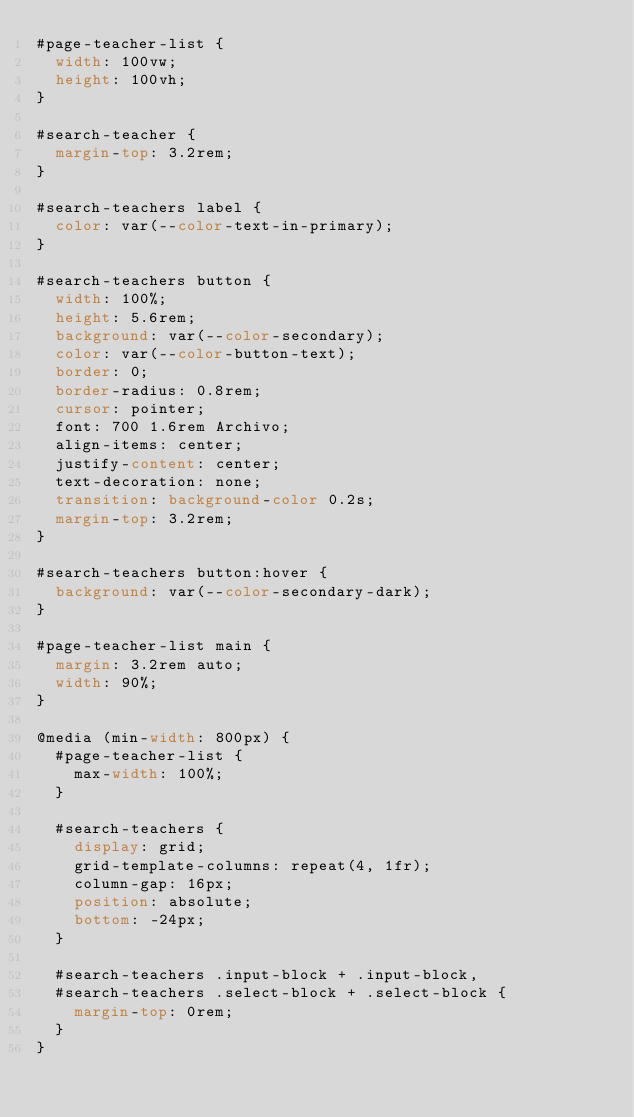Convert code to text. <code><loc_0><loc_0><loc_500><loc_500><_CSS_>#page-teacher-list {
  width: 100vw;
  height: 100vh;
}

#search-teacher {
  margin-top: 3.2rem;
}

#search-teachers label {
  color: var(--color-text-in-primary);
}

#search-teachers button {
  width: 100%;
  height: 5.6rem;
  background: var(--color-secondary);
  color: var(--color-button-text);
  border: 0;
  border-radius: 0.8rem;
  cursor: pointer;
  font: 700 1.6rem Archivo;
  align-items: center;
  justify-content: center;
  text-decoration: none;
  transition: background-color 0.2s;
  margin-top: 3.2rem;
}

#search-teachers button:hover {
  background: var(--color-secondary-dark);
}

#page-teacher-list main {
  margin: 3.2rem auto;
  width: 90%;
}

@media (min-width: 800px) {
  #page-teacher-list {
    max-width: 100%;
  }

  #search-teachers {
    display: grid;
    grid-template-columns: repeat(4, 1fr);
    column-gap: 16px;
    position: absolute;
    bottom: -24px;
  }

  #search-teachers .input-block + .input-block,
  #search-teachers .select-block + .select-block {
    margin-top: 0rem;
  }
}
</code> 